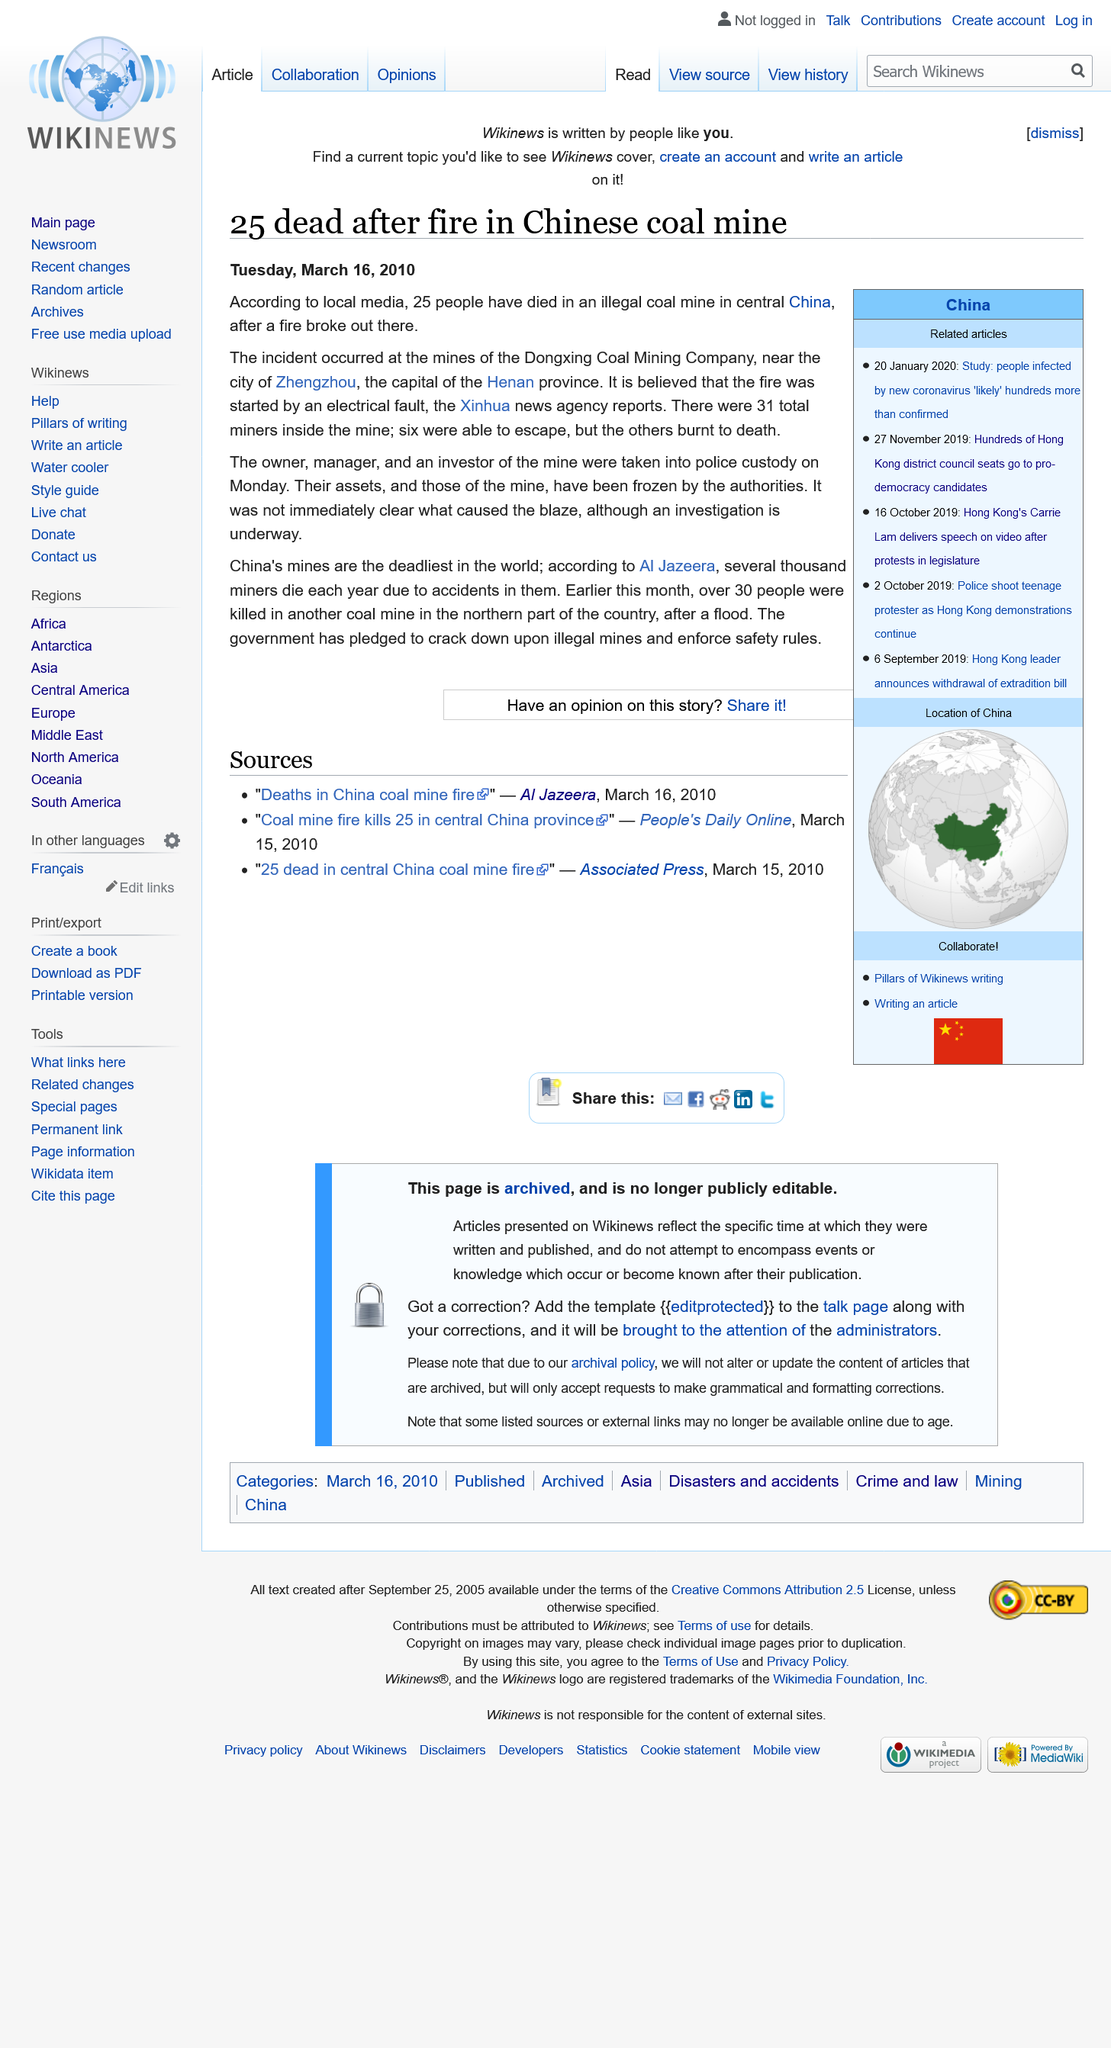Outline some significant characteristics in this image. Twenty-five miners lost their lives in a coal mine fire in Henan province in March 2010. The tragic death of 25 coal miners in Henin province in March 2010 was caused by a fire. Zhengzhou, the capital city of Henin province, is located in the Henan province of China. 